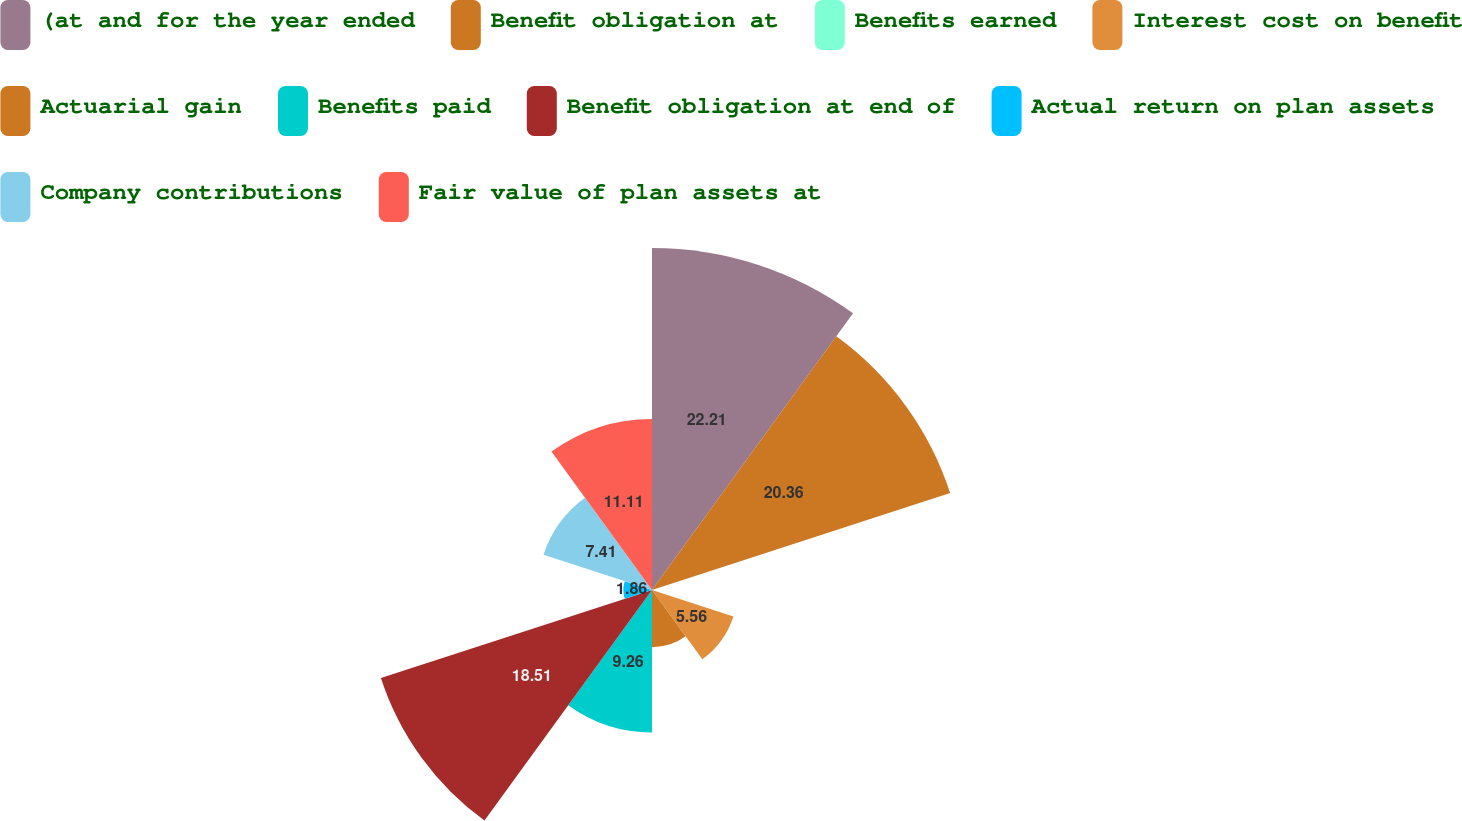<chart> <loc_0><loc_0><loc_500><loc_500><pie_chart><fcel>(at and for the year ended<fcel>Benefit obligation at<fcel>Benefits earned<fcel>Interest cost on benefit<fcel>Actuarial gain<fcel>Benefits paid<fcel>Benefit obligation at end of<fcel>Actual return on plan assets<fcel>Company contributions<fcel>Fair value of plan assets at<nl><fcel>22.21%<fcel>20.36%<fcel>0.01%<fcel>5.56%<fcel>3.71%<fcel>9.26%<fcel>18.51%<fcel>1.86%<fcel>7.41%<fcel>11.11%<nl></chart> 